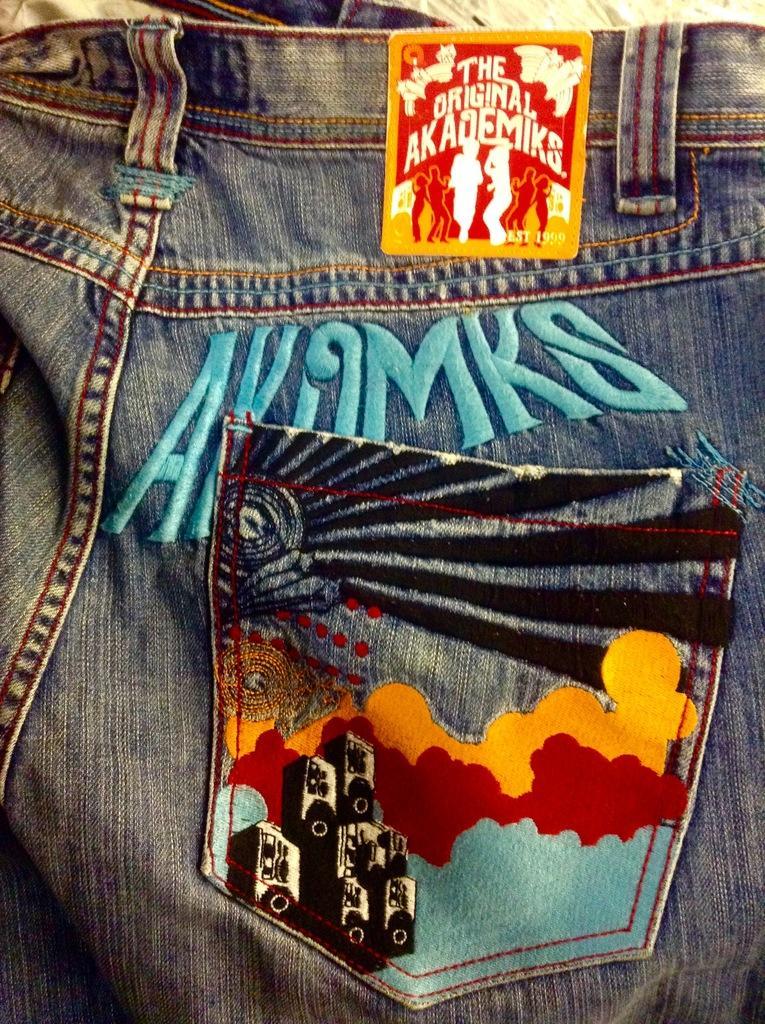How would you summarize this image in a sentence or two? In this picture, we see a blue jeans with some text written in blue color. We see a pocket and it is in blue, black, red and yellow color. At the top, we see a square shape sticker like thing with some text written on it. It is in yellow, red and white color. 